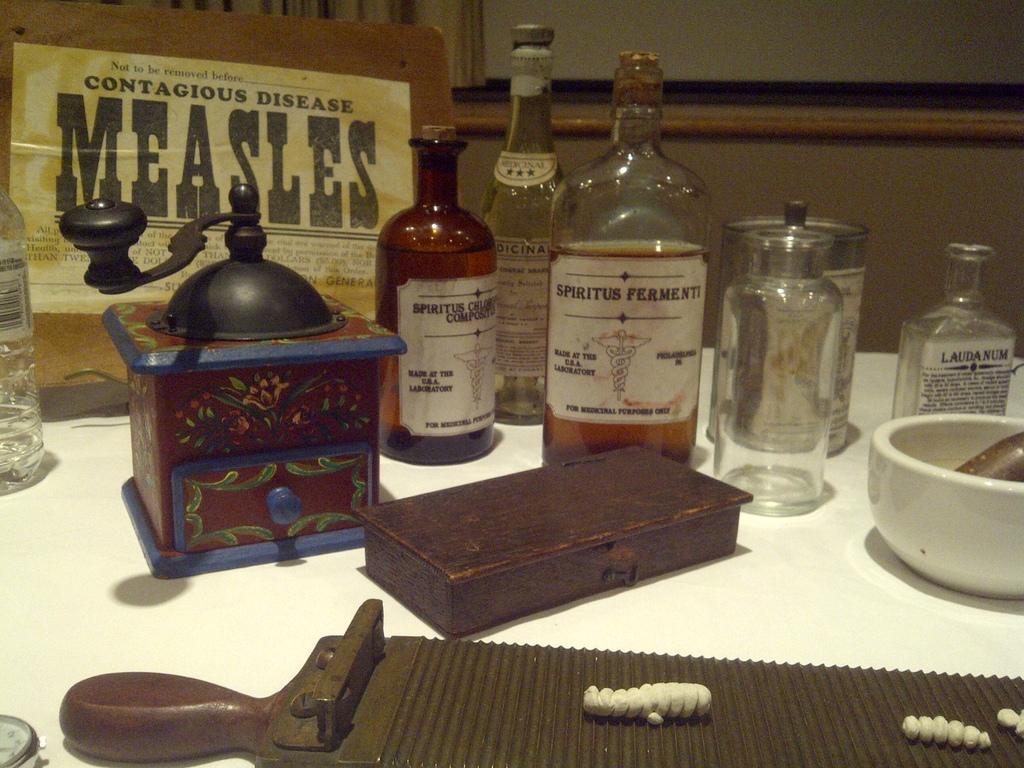Can you describe this image briefly? In this image there are group of bottles kept on the table. There is a box, bowl, and a designer box on the table. In the background there is a wall and a board with the name contagious disease measles. 